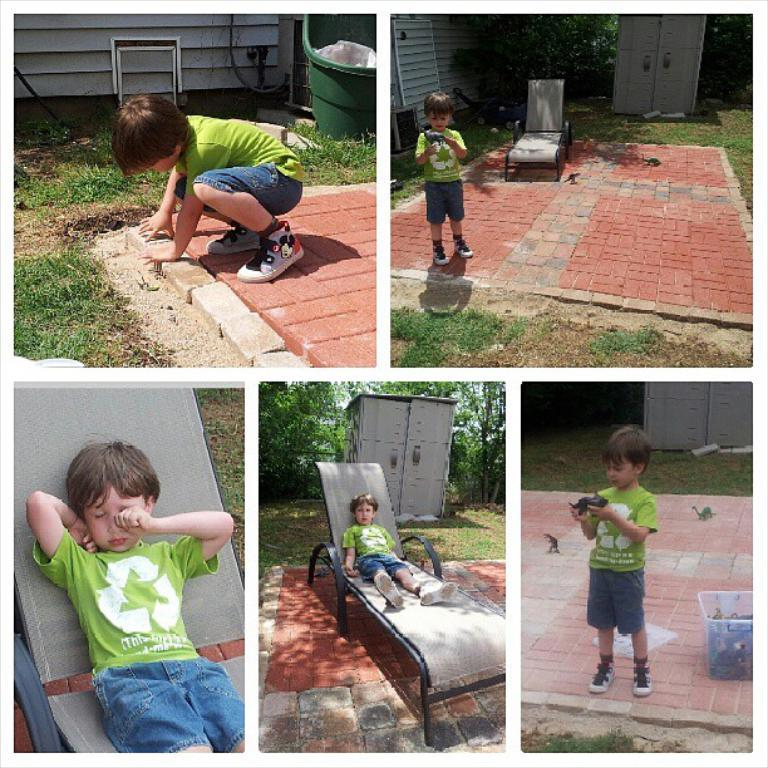What is the main subject of the image? The main subject of the image is a boy. What is the boy doing in the image? The boy is standing and sitting on a bench. What can be seen in the background of the image? There are trees in the background of the image. What flavor of chalk is the boy using to draw on the bench? There is no chalk present in the image, and therefore no flavor can be determined. 